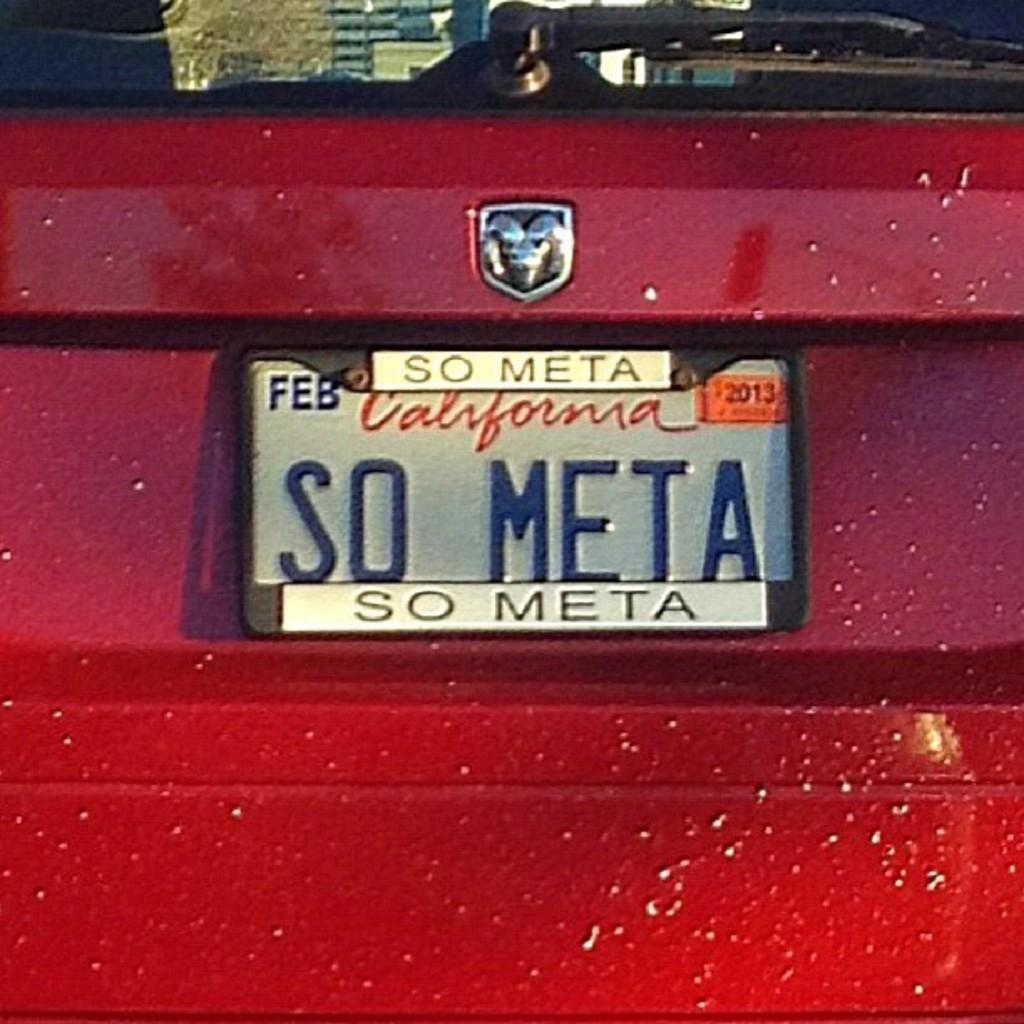<image>
Offer a succinct explanation of the picture presented. A car's license plate is so meta, both on the frame and on the plate itself. 